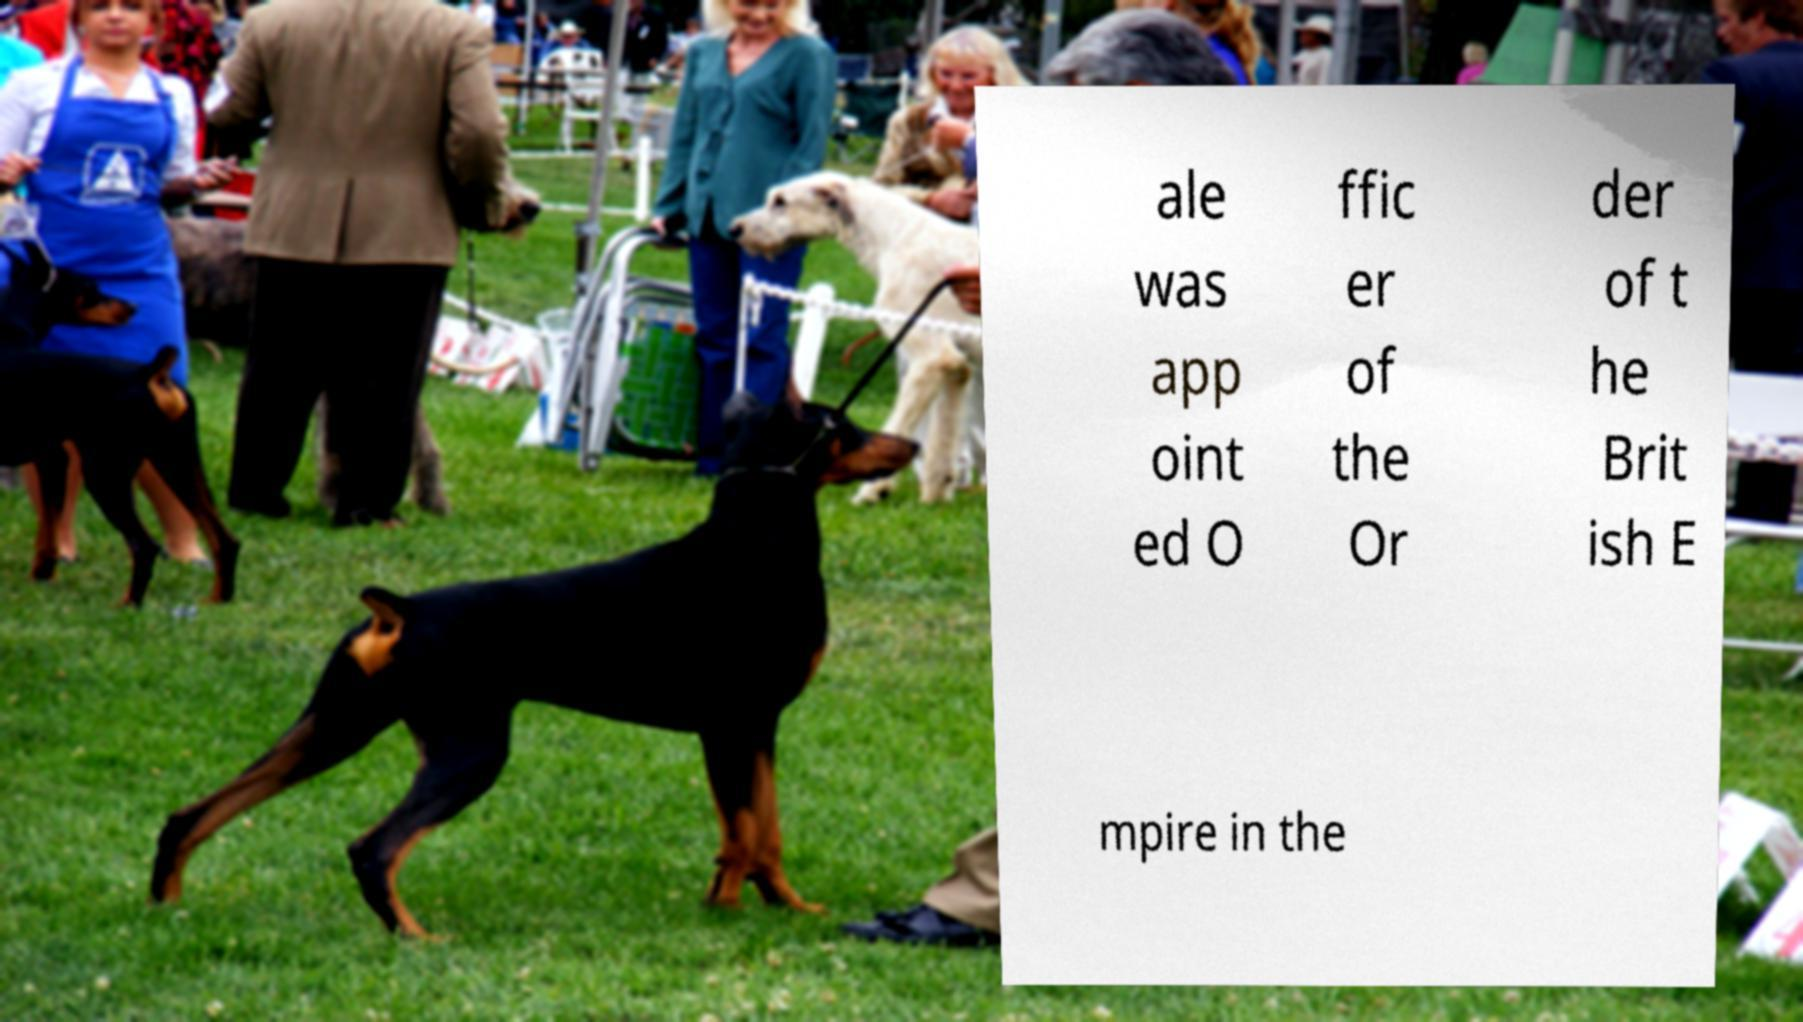There's text embedded in this image that I need extracted. Can you transcribe it verbatim? ale was app oint ed O ffic er of the Or der of t he Brit ish E mpire in the 